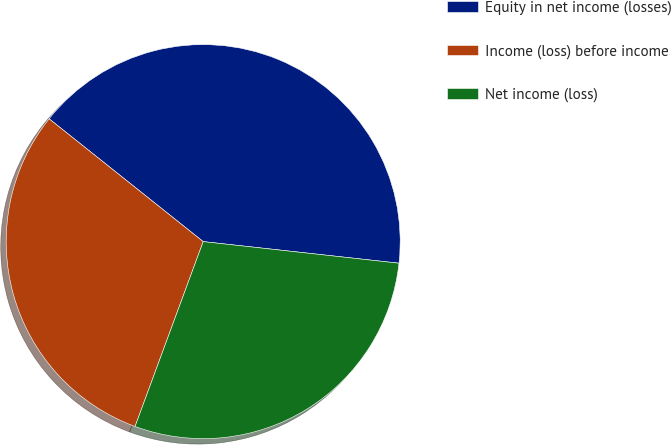Convert chart. <chart><loc_0><loc_0><loc_500><loc_500><pie_chart><fcel>Equity in net income (losses)<fcel>Income (loss) before income<fcel>Net income (loss)<nl><fcel>41.04%<fcel>30.09%<fcel>28.87%<nl></chart> 